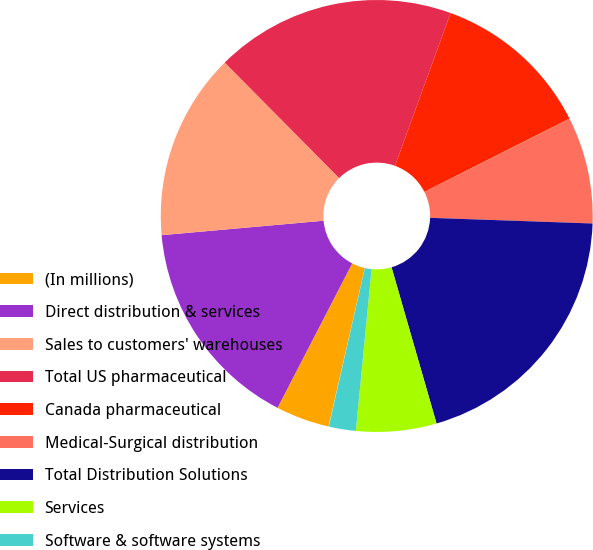<chart> <loc_0><loc_0><loc_500><loc_500><pie_chart><fcel>(In millions)<fcel>Direct distribution & services<fcel>Sales to customers' warehouses<fcel>Total US pharmaceutical<fcel>Canada pharmaceutical<fcel>Medical-Surgical distribution<fcel>Total Distribution Solutions<fcel>Services<fcel>Software & software systems<fcel>Hardware<nl><fcel>4.01%<fcel>15.99%<fcel>13.99%<fcel>17.98%<fcel>12.0%<fcel>8.0%<fcel>19.98%<fcel>6.01%<fcel>2.02%<fcel>0.02%<nl></chart> 